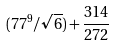<formula> <loc_0><loc_0><loc_500><loc_500>( 7 7 ^ { 9 } / \sqrt { 6 } ) + \frac { 3 1 4 } { 2 7 2 }</formula> 